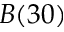Convert formula to latex. <formula><loc_0><loc_0><loc_500><loc_500>B ( 3 0 )</formula> 